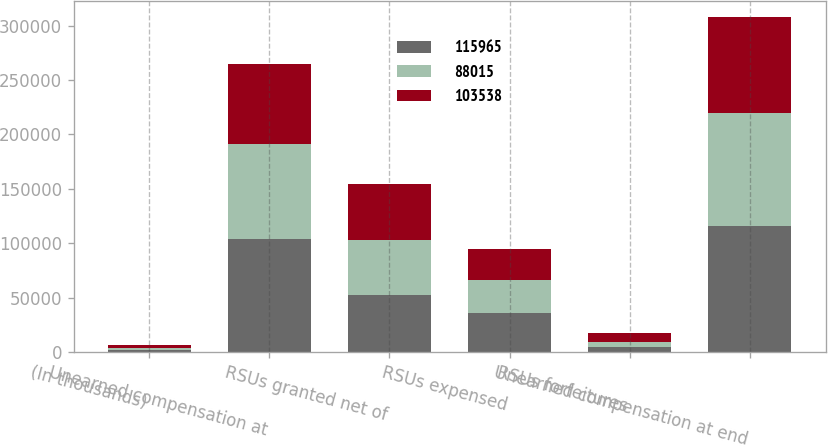<chart> <loc_0><loc_0><loc_500><loc_500><stacked_bar_chart><ecel><fcel>(In thousands)<fcel>Unearned compensation at<fcel>RSUs granted net of<fcel>RSUs expensed<fcel>RSUs forfeitures<fcel>Unearned compensation at end<nl><fcel>115965<fcel>2016<fcel>103538<fcel>52697<fcel>35585<fcel>4685<fcel>115965<nl><fcel>88015<fcel>2015<fcel>88015<fcel>50442<fcel>30691<fcel>4228<fcel>103538<nl><fcel>103538<fcel>2014<fcel>73205<fcel>51575<fcel>27966<fcel>8799<fcel>88015<nl></chart> 